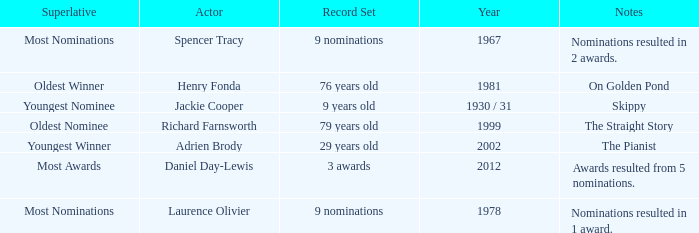What year was the the youngest nominee a winner? 1930 / 31. 